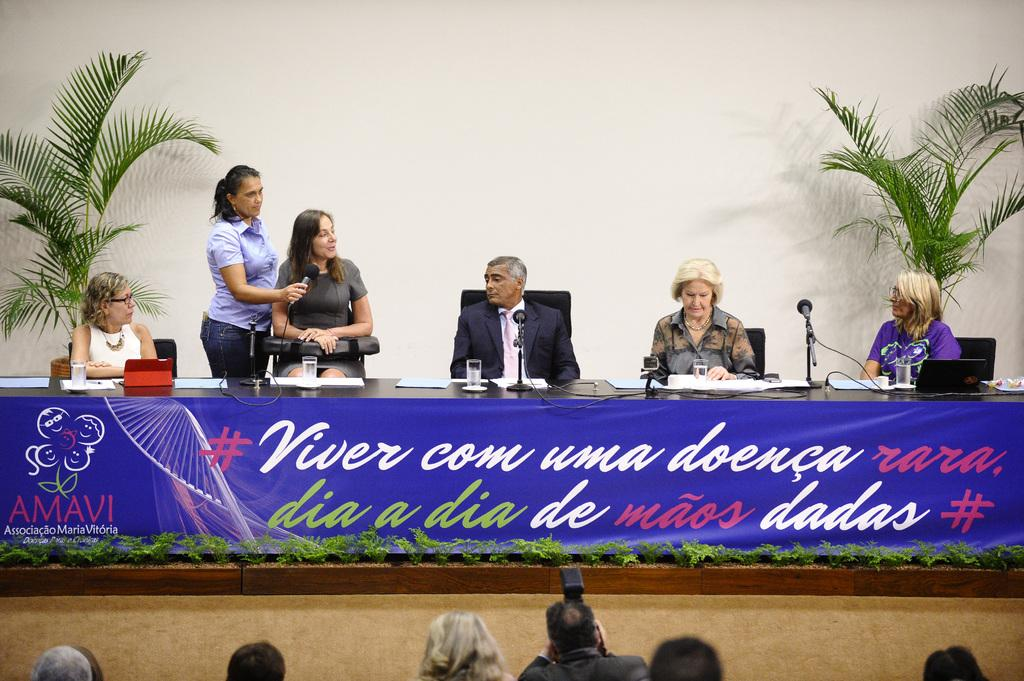What type of furniture is present in the image? There are chairs in the image. Who or what can be seen in the image? There are people in the image. What objects are used for amplifying sound in the image? There are microphones (mikes) in the image. What type of tableware is present in the image? There are glasses in the image. What electronic device is present in the image? There is a laptop in the image. What type of greenery is present in the image? There are plants in the image. What type of signage is present in the image? There is a banner with text in the image. What arithmetic problem is being solved on the laptop in the image? There is no arithmetic problem visible on the laptop in the image. How many people are sitting on the fifth chair in the image? There is no mention of a fifth chair in the image, and the number of people cannot be determined from the provided facts. 